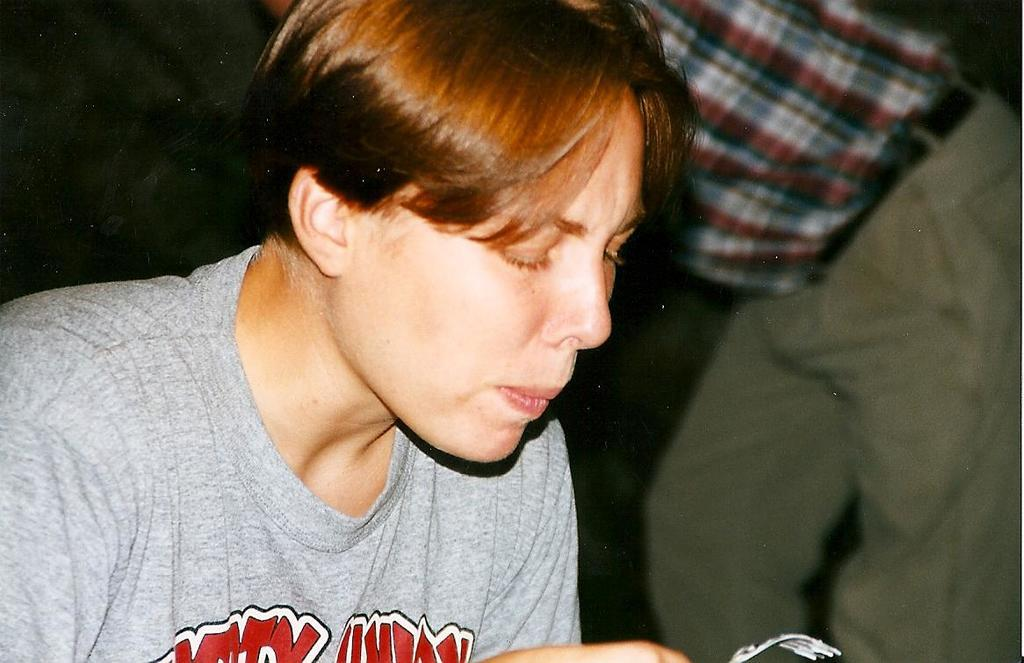What is the person in the image holding? The person is holding a fork in the image. Can you describe the other person in the image? There is another person standing in the image. What can be observed about the background of the image? The background of the image is dark. What type of toad can be seen hopping in the image? There is no toad present in the image; it only features two people and a fork. How does the ray of light affect the image? There is no mention of a ray of light in the image; the background is simply described as dark. 